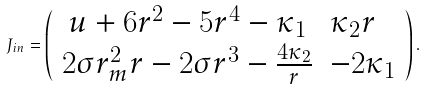<formula> <loc_0><loc_0><loc_500><loc_500>J _ { i n } = \left ( \begin{array} { c l c r } u + 6 r ^ { 2 } - 5 r ^ { 4 } - \kappa _ { 1 } & \kappa _ { 2 } r \\ 2 \sigma r _ { m } ^ { 2 } r - 2 \sigma r ^ { 3 } - \frac { 4 \kappa _ { 2 } } { r } & - 2 \kappa _ { 1 } \end{array} \right ) .</formula> 